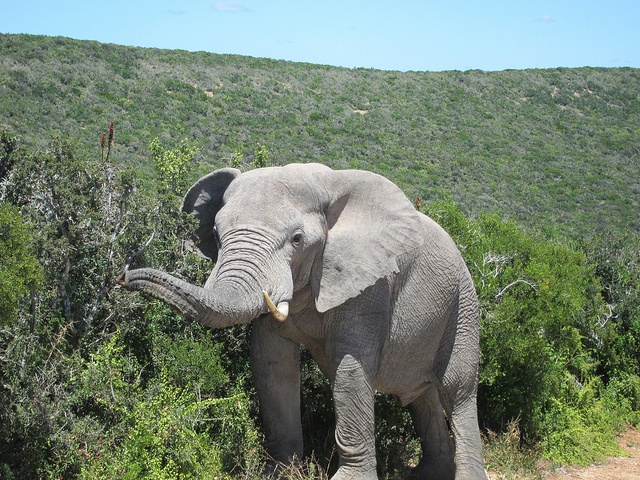Describe the objects in this image and their specific colors. I can see a elephant in lightblue, gray, darkgray, black, and lightgray tones in this image. 